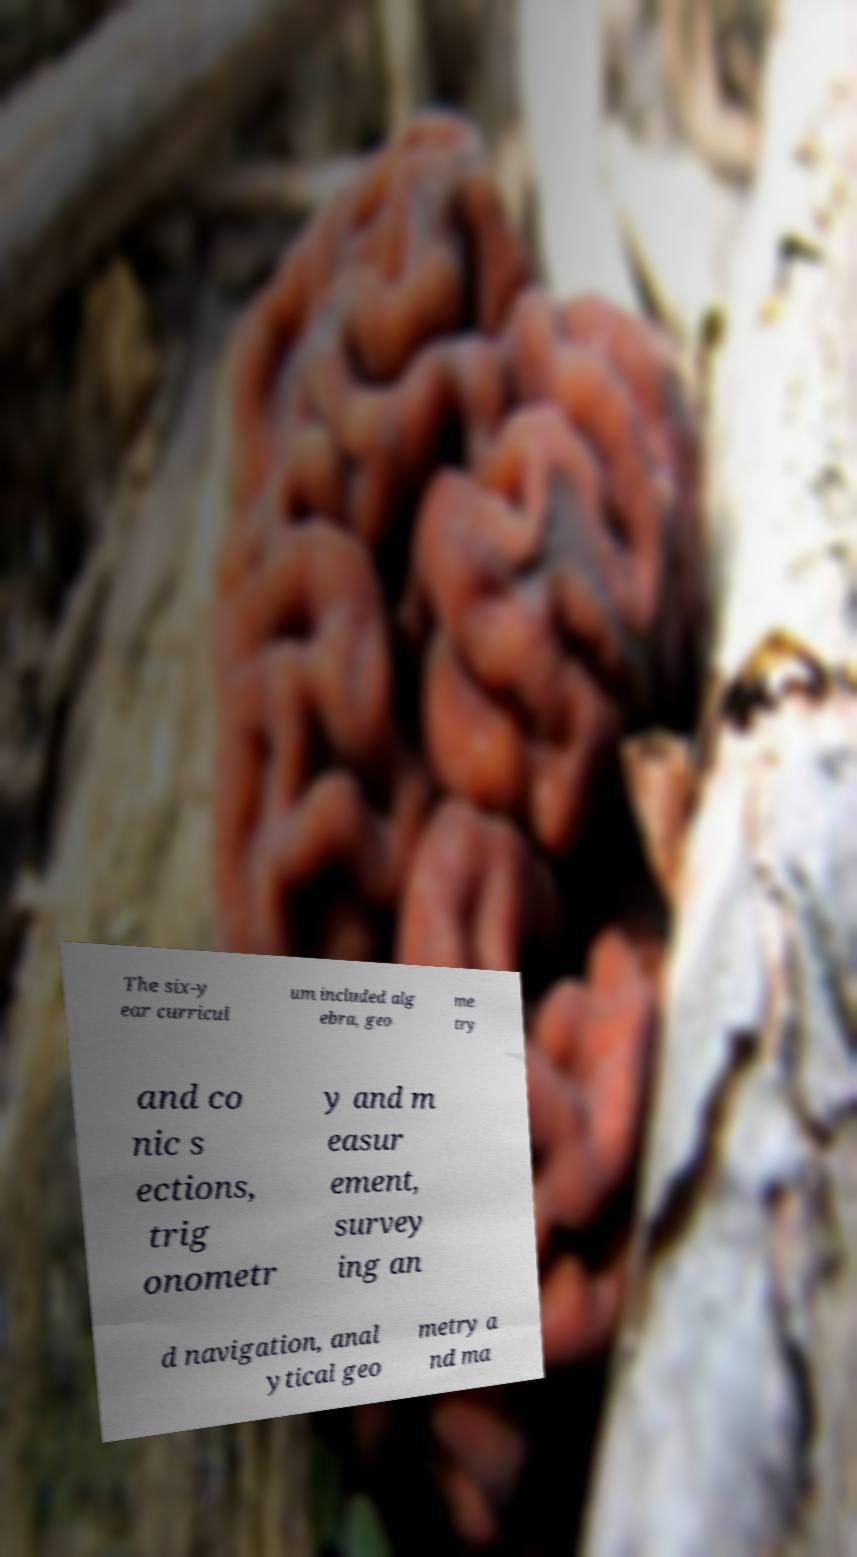There's text embedded in this image that I need extracted. Can you transcribe it verbatim? The six-y ear curricul um included alg ebra, geo me try and co nic s ections, trig onometr y and m easur ement, survey ing an d navigation, anal ytical geo metry a nd ma 